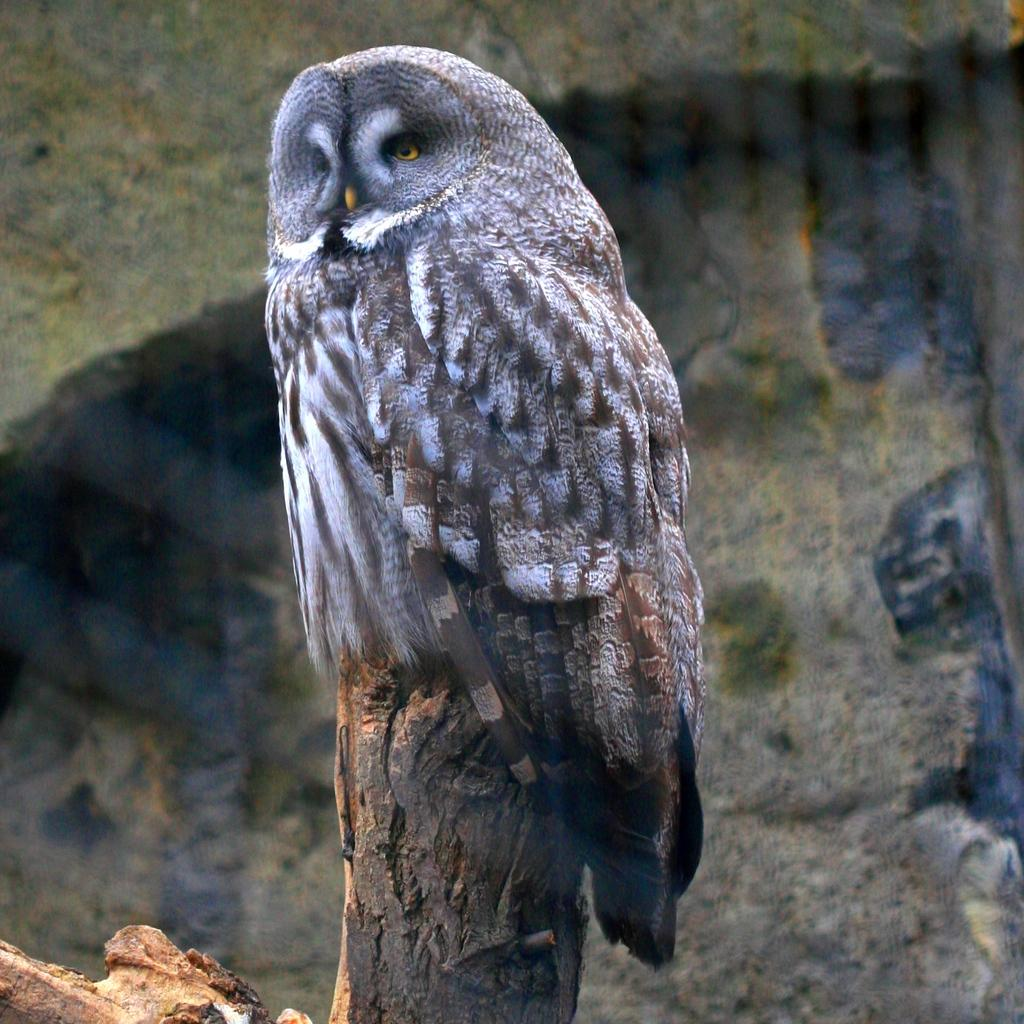What type of animal is in the image? There is an owl in the image. How is the owl positioned in the image? The owl is on a wooden stick. What can be seen in the background of the image? There is a wall in the background of the image. What type of waves can be seen in the image? There are no waves present in the image; it features an owl on a wooden stick with a wall in the background. 